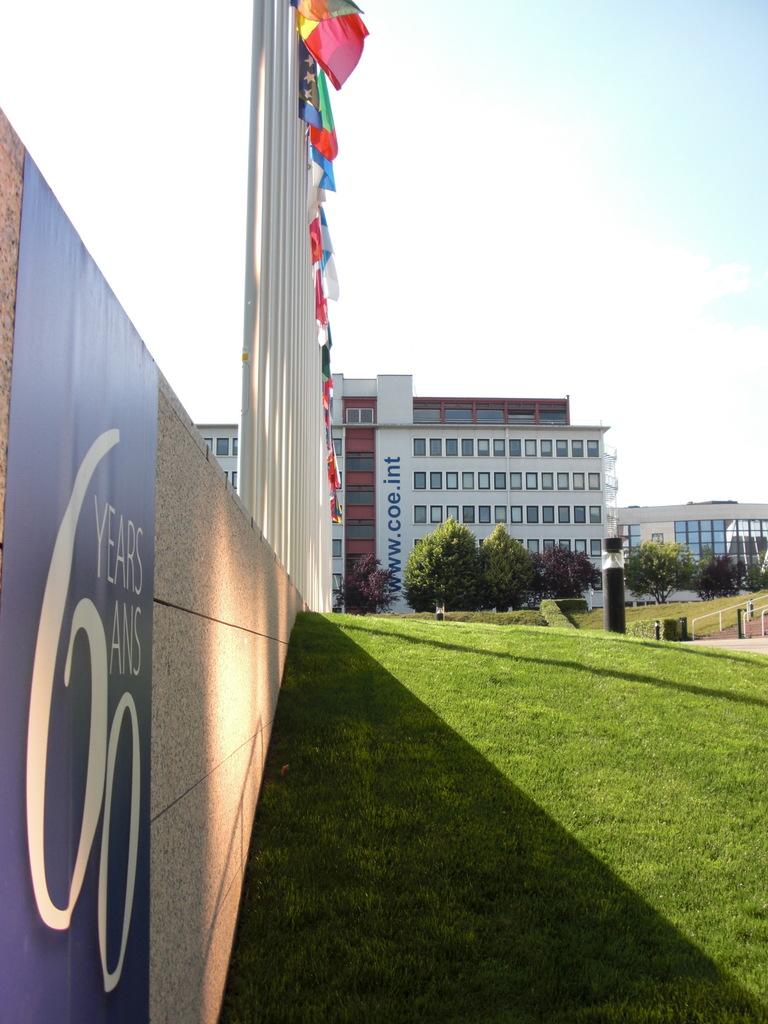How many years?
Make the answer very short. 60. What is the website on the building?
Your answer should be compact. Www.coe.int. 